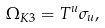Convert formula to latex. <formula><loc_0><loc_0><loc_500><loc_500>\Omega _ { K 3 } = T ^ { u } \sigma _ { u } ,</formula> 